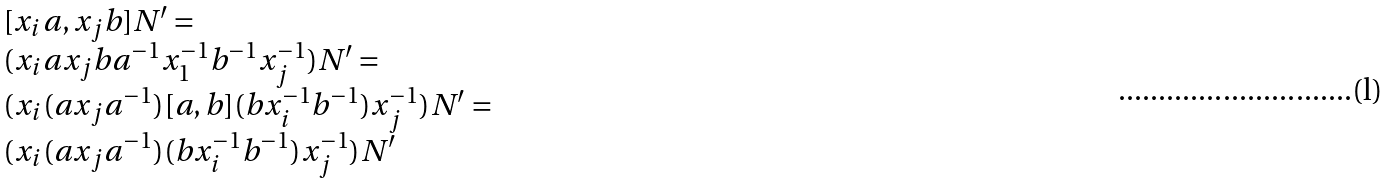Convert formula to latex. <formula><loc_0><loc_0><loc_500><loc_500>\begin{array} { l } [ x _ { i } a , x _ { j } b ] N ^ { \prime } = \\ ( x _ { i } a x _ { j } b a ^ { - 1 } x _ { 1 } ^ { - 1 } b ^ { - 1 } x _ { j } ^ { - 1 } ) N ^ { \prime } = \\ ( x _ { i } ( a x _ { j } a ^ { - 1 } ) [ a , b ] ( b x _ { i } ^ { - 1 } b ^ { - 1 } ) x _ { j } ^ { - 1 } ) N ^ { \prime } = \\ ( x _ { i } ( a x _ { j } a ^ { - 1 } ) ( b x _ { i } ^ { - 1 } b ^ { - 1 } ) x _ { j } ^ { - 1 } ) N ^ { \prime } \end{array}</formula> 